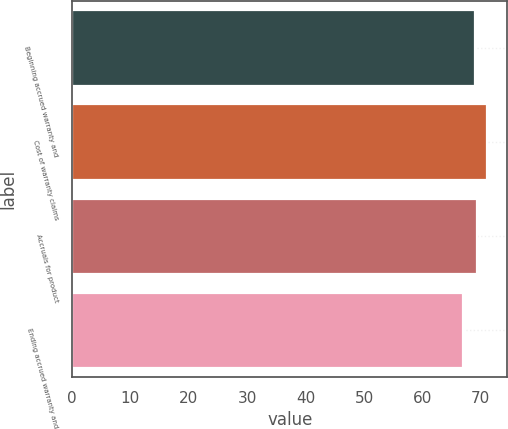Convert chart. <chart><loc_0><loc_0><loc_500><loc_500><bar_chart><fcel>Beginning accrued warranty and<fcel>Cost of warranty claims<fcel>Accruals for product<fcel>Ending accrued warranty and<nl><fcel>69<fcel>71<fcel>69.4<fcel>67<nl></chart> 